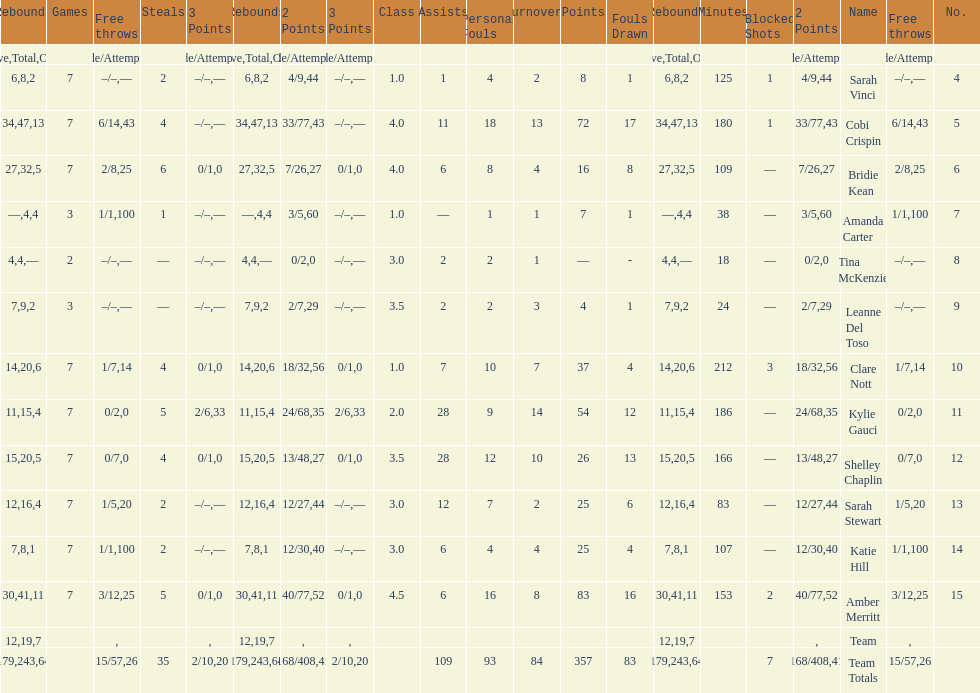Which player had the most total points? Amber Merritt. 